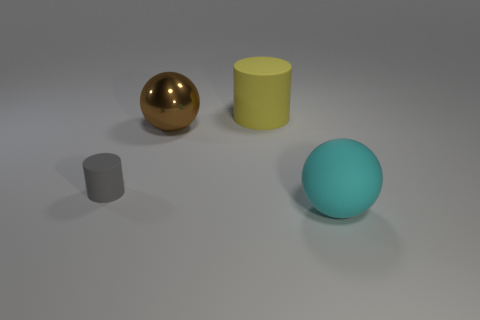Are there any other things that are the same material as the brown object?
Keep it short and to the point. No. There is a rubber thing that is behind the gray rubber cylinder; how many matte things are to the left of it?
Your answer should be compact. 1. What number of other objects are there of the same size as the brown metal object?
Provide a short and direct response. 2. Does the big rubber thing that is behind the small cylinder have the same shape as the shiny object?
Provide a short and direct response. No. What number of objects are both to the right of the big brown shiny thing and behind the tiny thing?
Offer a very short reply. 1. What is the tiny object made of?
Offer a terse response. Rubber. Are there any other things that have the same color as the big metallic object?
Your answer should be compact. No. Is the cyan object made of the same material as the tiny thing?
Offer a terse response. Yes. There is a large ball that is behind the large matte object that is in front of the small gray object; what number of matte cylinders are to the right of it?
Offer a terse response. 1. What number of cyan rubber objects are there?
Your response must be concise. 1. 